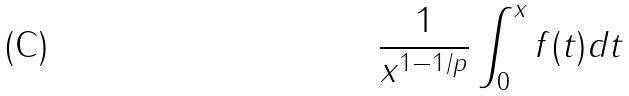Convert formula to latex. <formula><loc_0><loc_0><loc_500><loc_500>\frac { 1 } { x ^ { 1 - 1 / p } } \int _ { 0 } ^ { x } f ( t ) d t</formula> 